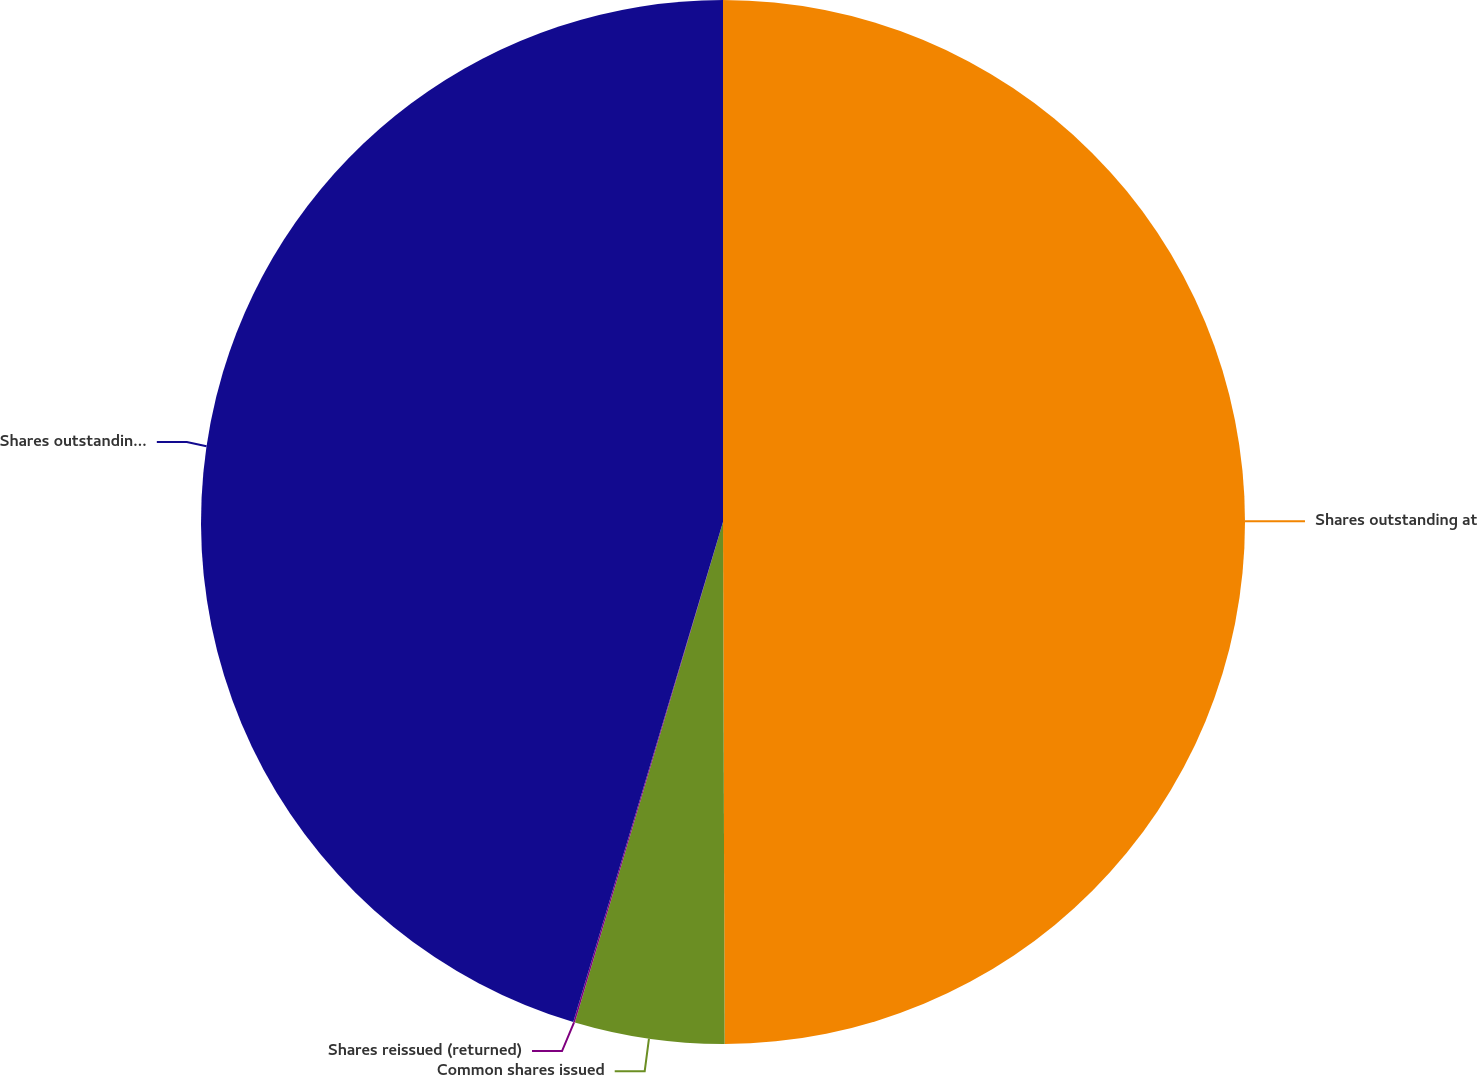<chart> <loc_0><loc_0><loc_500><loc_500><pie_chart><fcel>Shares outstanding at<fcel>Common shares issued<fcel>Shares reissued (returned)<fcel>Shares outstanding at end of<nl><fcel>49.95%<fcel>4.63%<fcel>0.05%<fcel>45.37%<nl></chart> 